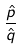Convert formula to latex. <formula><loc_0><loc_0><loc_500><loc_500>\frac { \hat { p } } { \hat { q } }</formula> 